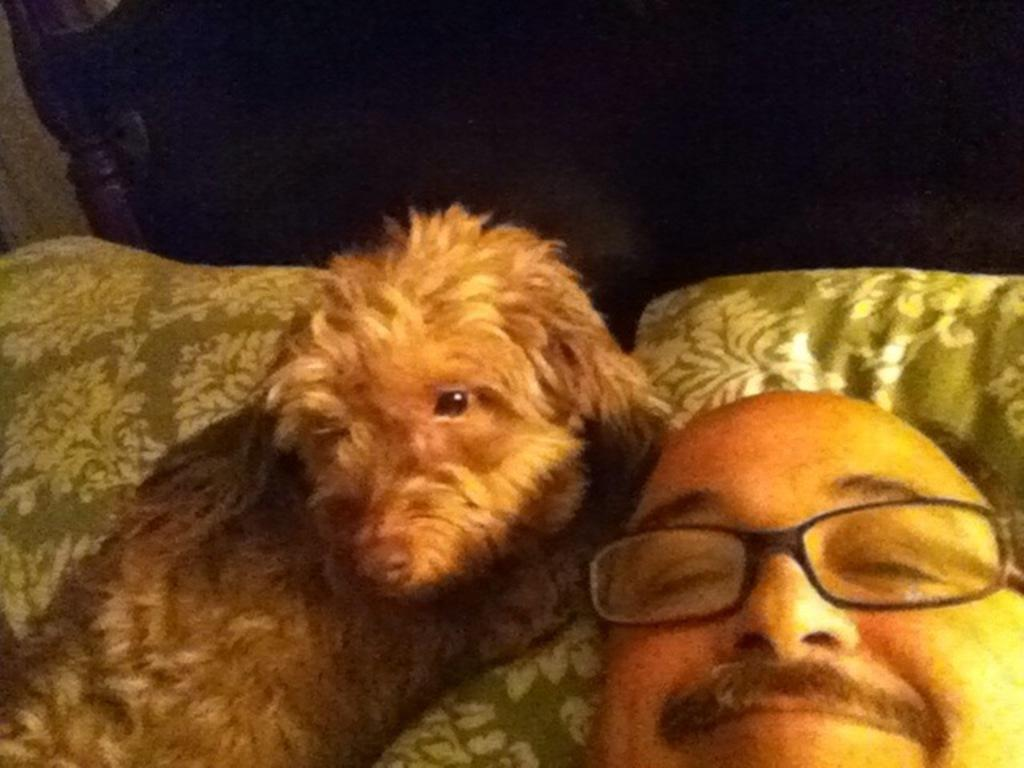Who is present in the image? There is a man in the image. What other living creature is present in the image? There is a dog in the image. What are the man and the dog doing in the image? Both the man and the dog are sleeping on a bed. Can you describe the bed in the image? There is a brown color bed in the background of the image. How many geese are present in the image? There are no geese present in the image; it features a man and a dog sleeping on a bed. What type of clam is visible on the bed in the image? There is no clam present on the bed in the image. 